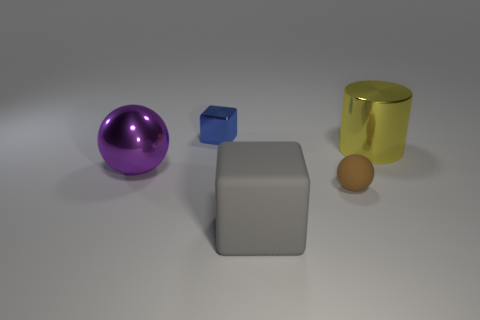If the small blue cube weighs 100 grams, how would you estimate the weights of the other objects? Assuming the objects are made from materials with typical densities, the purple sphere might be around 250 grams, the large gray rubber cube could be about 500 grams, and the golden cylinder might weigh roughly 300 grams, while the small brown object, which looks like an egg, may be around 50 grams. 